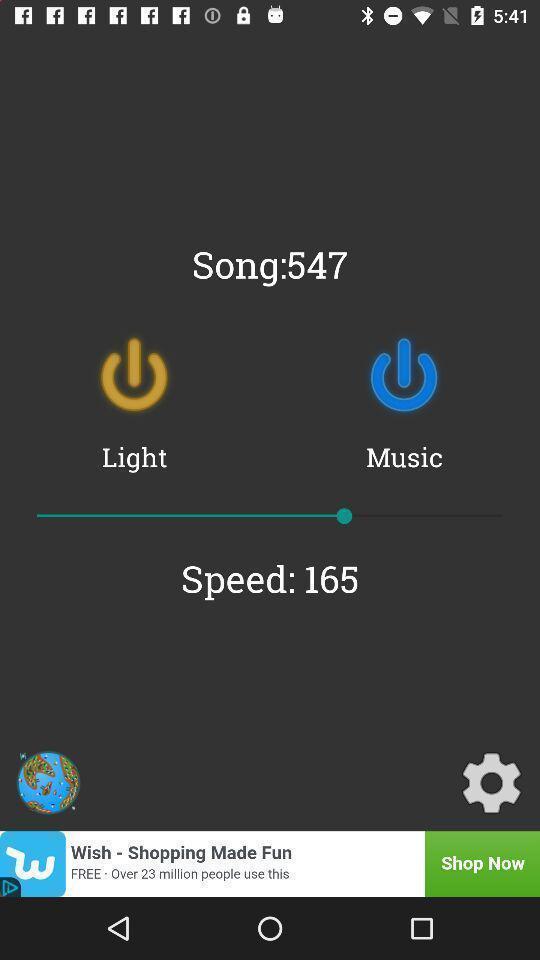Describe this image in words. Page showing power buttons on two colors. 